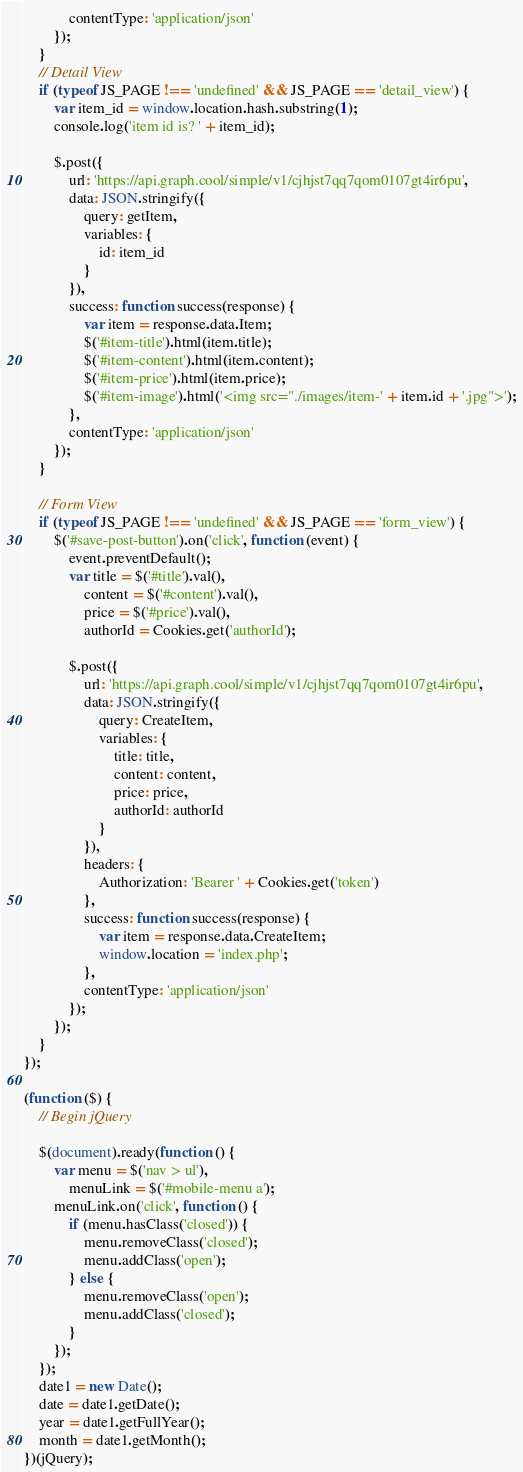<code> <loc_0><loc_0><loc_500><loc_500><_JavaScript_>
            contentType: 'application/json'
        });
    }
    // Detail View
    if (typeof JS_PAGE !== 'undefined' && JS_PAGE == 'detail_view') {
        var item_id = window.location.hash.substring(1);
        console.log('item id is? ' + item_id);

        $.post({
            url: 'https://api.graph.cool/simple/v1/cjhjst7qq7qom0107gt4ir6pu',
            data: JSON.stringify({
                query: getItem,
                variables: {
                    id: item_id
                }
            }),
            success: function success(response) {
                var item = response.data.Item;
                $('#item-title').html(item.title);
                $('#item-content').html(item.content);
                $('#item-price').html(item.price);
                $('#item-image').html('<img src="./images/item-' + item.id + '.jpg">');
            },
            contentType: 'application/json'
        });
    }

    // Form View
    if (typeof JS_PAGE !== 'undefined' && JS_PAGE == 'form_view') {
        $('#save-post-button').on('click', function (event) {
            event.preventDefault();
            var title = $('#title').val(),
                content = $('#content').val(),
                price = $('#price').val(),
                authorId = Cookies.get('authorId');

            $.post({
                url: 'https://api.graph.cool/simple/v1/cjhjst7qq7qom0107gt4ir6pu',
                data: JSON.stringify({
                    query: CreateItem,
                    variables: {
                        title: title,
                        content: content,
                        price: price,
                        authorId: authorId
                    }
                }),
                headers: {
                    Authorization: 'Bearer ' + Cookies.get('token')
                },
                success: function success(response) {
                    var item = response.data.CreateItem;
                    window.location = 'index.php';
                },
                contentType: 'application/json'
            });
        });
    }
});

(function ($) {
    // Begin jQuery

    $(document).ready(function () {
        var menu = $('nav > ul'),
            menuLink = $('#mobile-menu a');
        menuLink.on('click', function () {
            if (menu.hasClass('closed')) {
                menu.removeClass('closed');
                menu.addClass('open');
            } else {
                menu.removeClass('open');
                menu.addClass('closed');
            }
        });
    });
    date1 = new Date();
    date = date1.getDate();
    year = date1.getFullYear();
    month = date1.getMonth();
})(jQuery);
</code> 